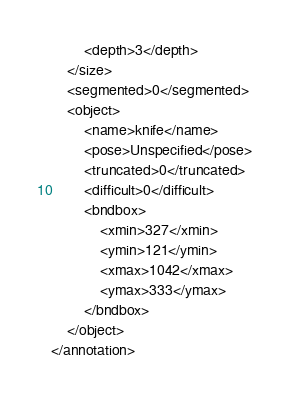<code> <loc_0><loc_0><loc_500><loc_500><_XML_>		<depth>3</depth>
	</size>
	<segmented>0</segmented>
	<object>
		<name>knife</name>
		<pose>Unspecified</pose>
		<truncated>0</truncated>
		<difficult>0</difficult>
		<bndbox>
			<xmin>327</xmin>
			<ymin>121</ymin>
			<xmax>1042</xmax>
			<ymax>333</ymax>
		</bndbox>
	</object>
</annotation>

</code> 